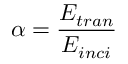Convert formula to latex. <formula><loc_0><loc_0><loc_500><loc_500>\alpha = \frac { E _ { t r a n } } { E _ { i n c i } }</formula> 